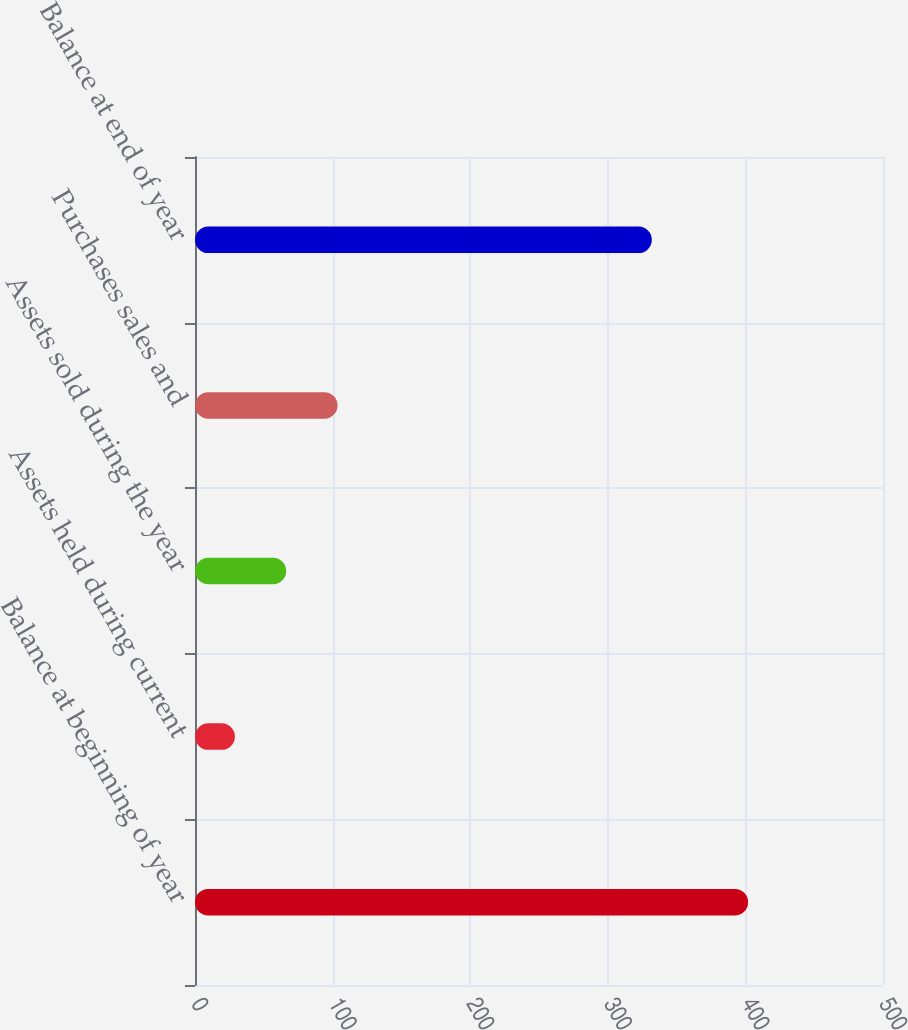Convert chart. <chart><loc_0><loc_0><loc_500><loc_500><bar_chart><fcel>Balance at beginning of year<fcel>Assets held during current<fcel>Assets sold during the year<fcel>Purchases sales and<fcel>Balance at end of year<nl><fcel>402<fcel>29<fcel>66.3<fcel>103.6<fcel>332<nl></chart> 